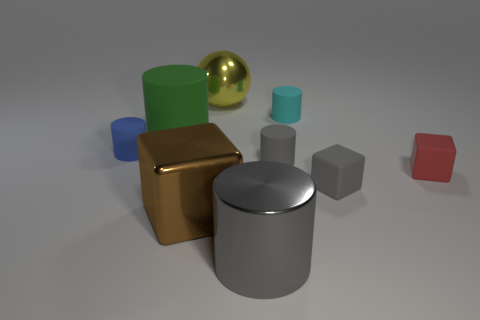The large gray object is what shape?
Give a very brief answer. Cylinder. Do the cyan matte object and the shiny object that is to the left of the big sphere have the same shape?
Give a very brief answer. No. There is a rubber cylinder that is the same color as the metallic cylinder; what is its size?
Your answer should be very brief. Small. Is there a small thing made of the same material as the big green cylinder?
Offer a very short reply. Yes. What is the color of the metallic block?
Offer a very short reply. Brown. Does the gray matte thing behind the small red rubber object have the same shape as the blue object?
Ensure brevity in your answer.  Yes. What is the shape of the small thing on the left side of the large cylinder that is on the right side of the block that is to the left of the large yellow metal ball?
Provide a succinct answer. Cylinder. There is a gray cylinder left of the tiny gray cylinder; what is its material?
Your answer should be very brief. Metal. The block that is the same size as the yellow metal object is what color?
Offer a terse response. Brown. What number of other objects are there of the same shape as the brown object?
Your answer should be compact. 2. 